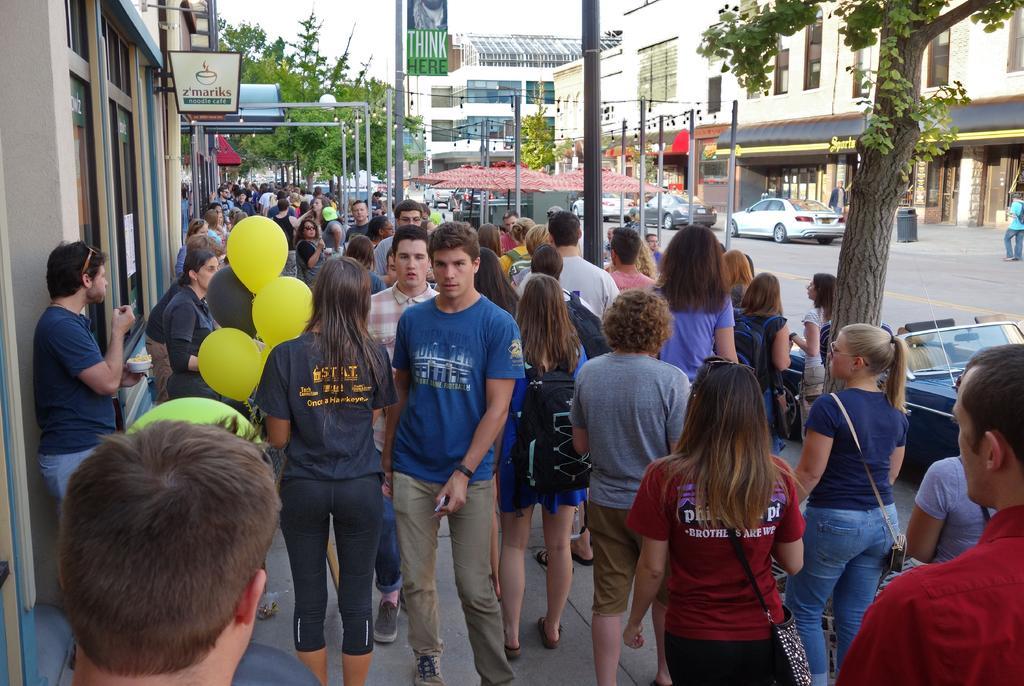How would you summarize this image in a sentence or two? In this image I can see, in the middle a woman is standing by holding the balloons. Beside her a man is walking, he wore blue color t-shirt, many people are walking on the foot path. On the right side there is a tree. In the middle there are cars and buildings. 